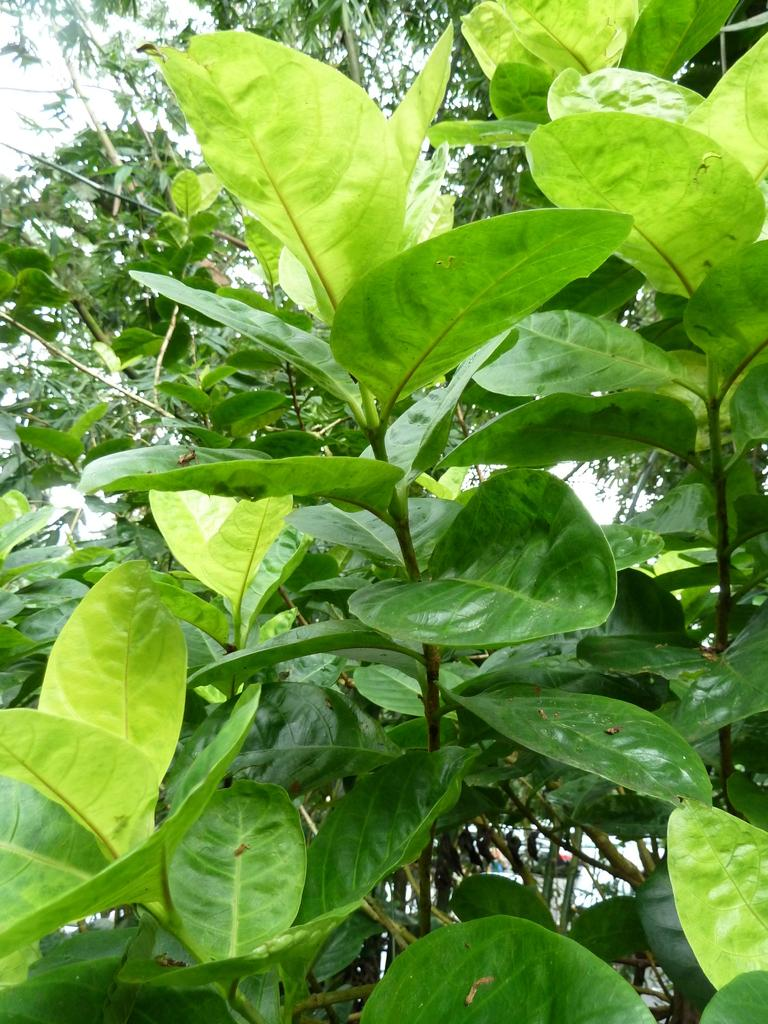What type of vegetation can be seen in the image? There are green leaves in the image. What color is the background of the image? The background of the image is white. What type of scarf is being knitted with the yarn in the image? There is no scarf or yarn present in the image; it only features green leaves and a white background. 